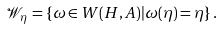Convert formula to latex. <formula><loc_0><loc_0><loc_500><loc_500>\mathcal { W } _ { \eta } = \{ \omega \in W ( H , A ) | \omega ( \eta ) = \eta \} \, .</formula> 